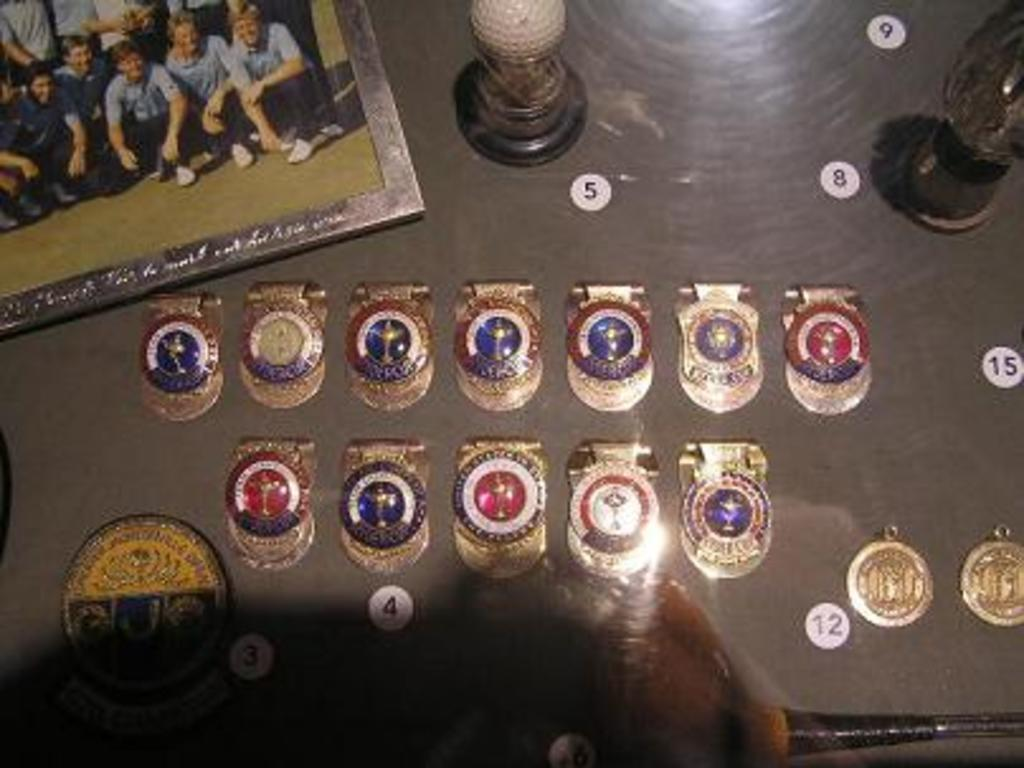<image>
Create a compact narrative representing the image presented. Many different metals on display with one near a number 4. 